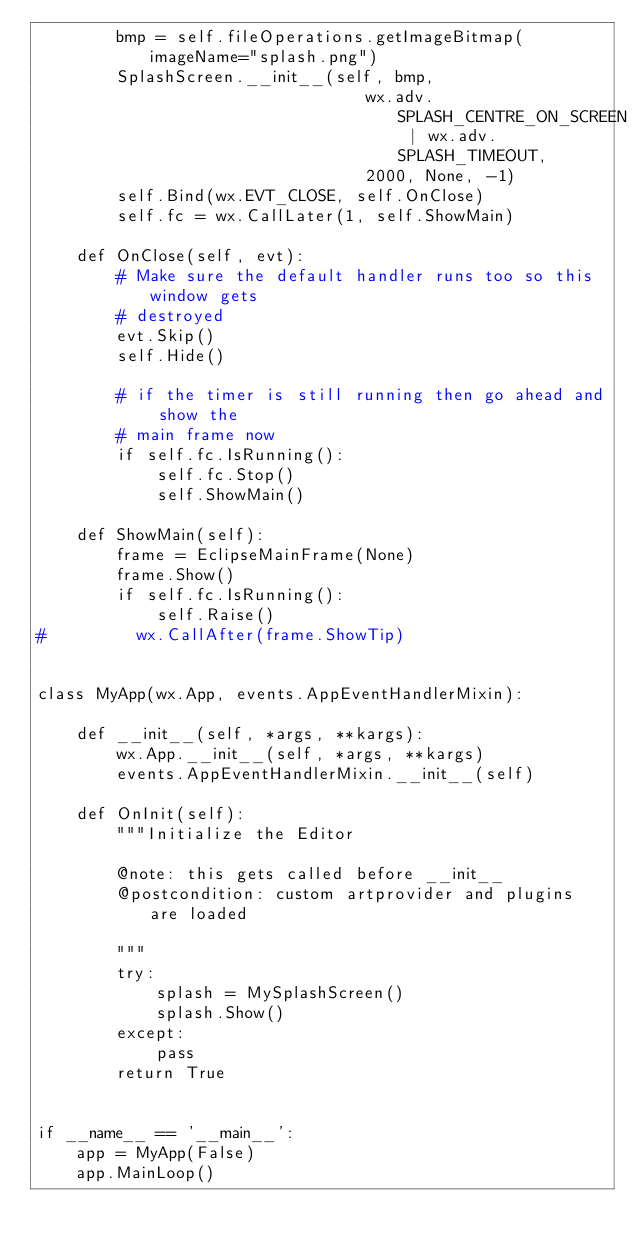Convert code to text. <code><loc_0><loc_0><loc_500><loc_500><_Python_>        bmp = self.fileOperations.getImageBitmap(imageName="splash.png")
        SplashScreen.__init__(self, bmp,
                                 wx.adv.SPLASH_CENTRE_ON_SCREEN | wx.adv.SPLASH_TIMEOUT,
                                 2000, None, -1)
        self.Bind(wx.EVT_CLOSE, self.OnClose)
        self.fc = wx.CallLater(1, self.ShowMain)

    def OnClose(self, evt):
        # Make sure the default handler runs too so this window gets
        # destroyed
        evt.Skip()
        self.Hide()

        # if the timer is still running then go ahead and show the
        # main frame now
        if self.fc.IsRunning():
            self.fc.Stop()
            self.ShowMain()

    def ShowMain(self):
        frame = EclipseMainFrame(None)
        frame.Show()
        if self.fc.IsRunning():
            self.Raise()
#         wx.CallAfter(frame.ShowTip)


class MyApp(wx.App, events.AppEventHandlerMixin):

    def __init__(self, *args, **kargs):
        wx.App.__init__(self, *args, **kargs)
        events.AppEventHandlerMixin.__init__(self)
        
    def OnInit(self):
        """Initialize the Editor
        
        @note: this gets called before __init__
        @postcondition: custom artprovider and plugins are loaded

        """
        try:
            splash = MySplashScreen()
            splash.Show()
        except:
            pass
        return True


if __name__ == '__main__':
    app = MyApp(False)
    app.MainLoop()
</code> 